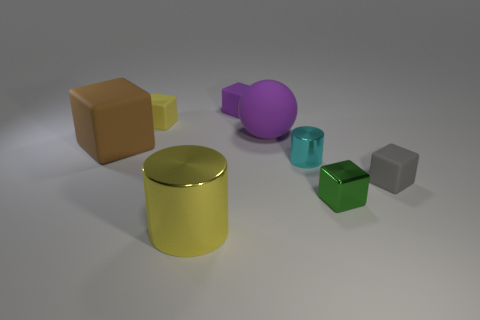Is there a purple ball that has the same size as the yellow cylinder?
Offer a terse response. Yes. Does the sphere have the same size as the metallic object that is to the right of the cyan metallic cylinder?
Make the answer very short. No. Is the number of balls that are to the right of the cyan thing the same as the number of cylinders that are behind the rubber sphere?
Keep it short and to the point. Yes. The small thing that is the same color as the large cylinder is what shape?
Give a very brief answer. Cube. What material is the large thing that is in front of the cyan metal cylinder?
Provide a short and direct response. Metal. Is the size of the shiny cube the same as the yellow matte thing?
Provide a short and direct response. Yes. Are there more green things that are right of the tiny gray cube than tiny cyan cylinders?
Make the answer very short. No. What size is the gray object that is made of the same material as the brown block?
Make the answer very short. Small. There is a big yellow object; are there any small metallic objects to the left of it?
Keep it short and to the point. No. Is the shape of the gray matte thing the same as the cyan metallic thing?
Provide a short and direct response. No. 